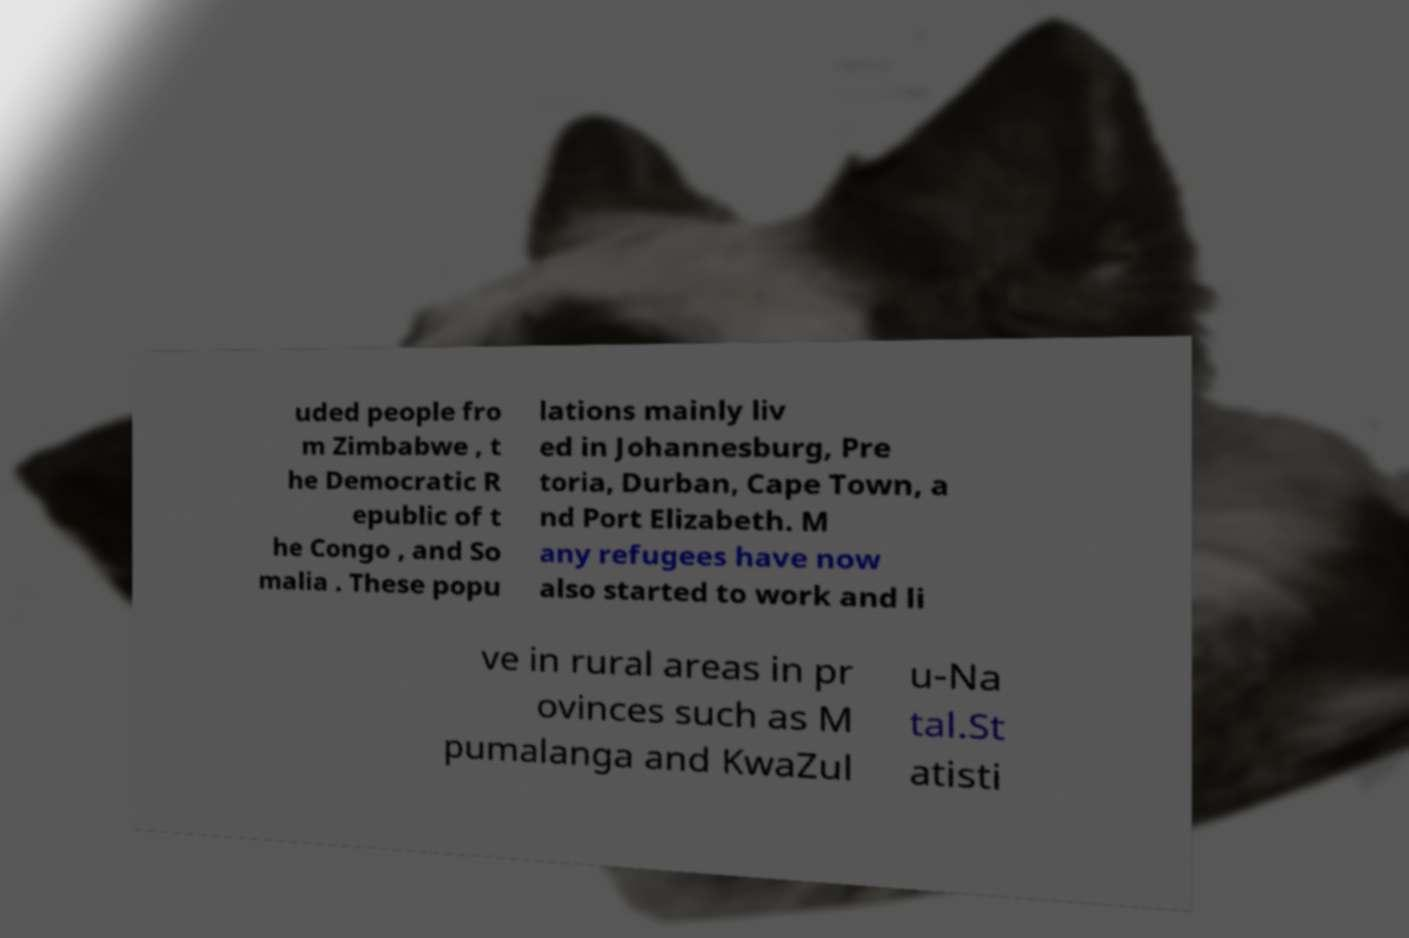Could you extract and type out the text from this image? uded people fro m Zimbabwe , t he Democratic R epublic of t he Congo , and So malia . These popu lations mainly liv ed in Johannesburg, Pre toria, Durban, Cape Town, a nd Port Elizabeth. M any refugees have now also started to work and li ve in rural areas in pr ovinces such as M pumalanga and KwaZul u-Na tal.St atisti 